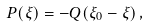<formula> <loc_0><loc_0><loc_500><loc_500>P ( \xi ) = - Q ( \xi _ { 0 } - \xi ) \, ,</formula> 